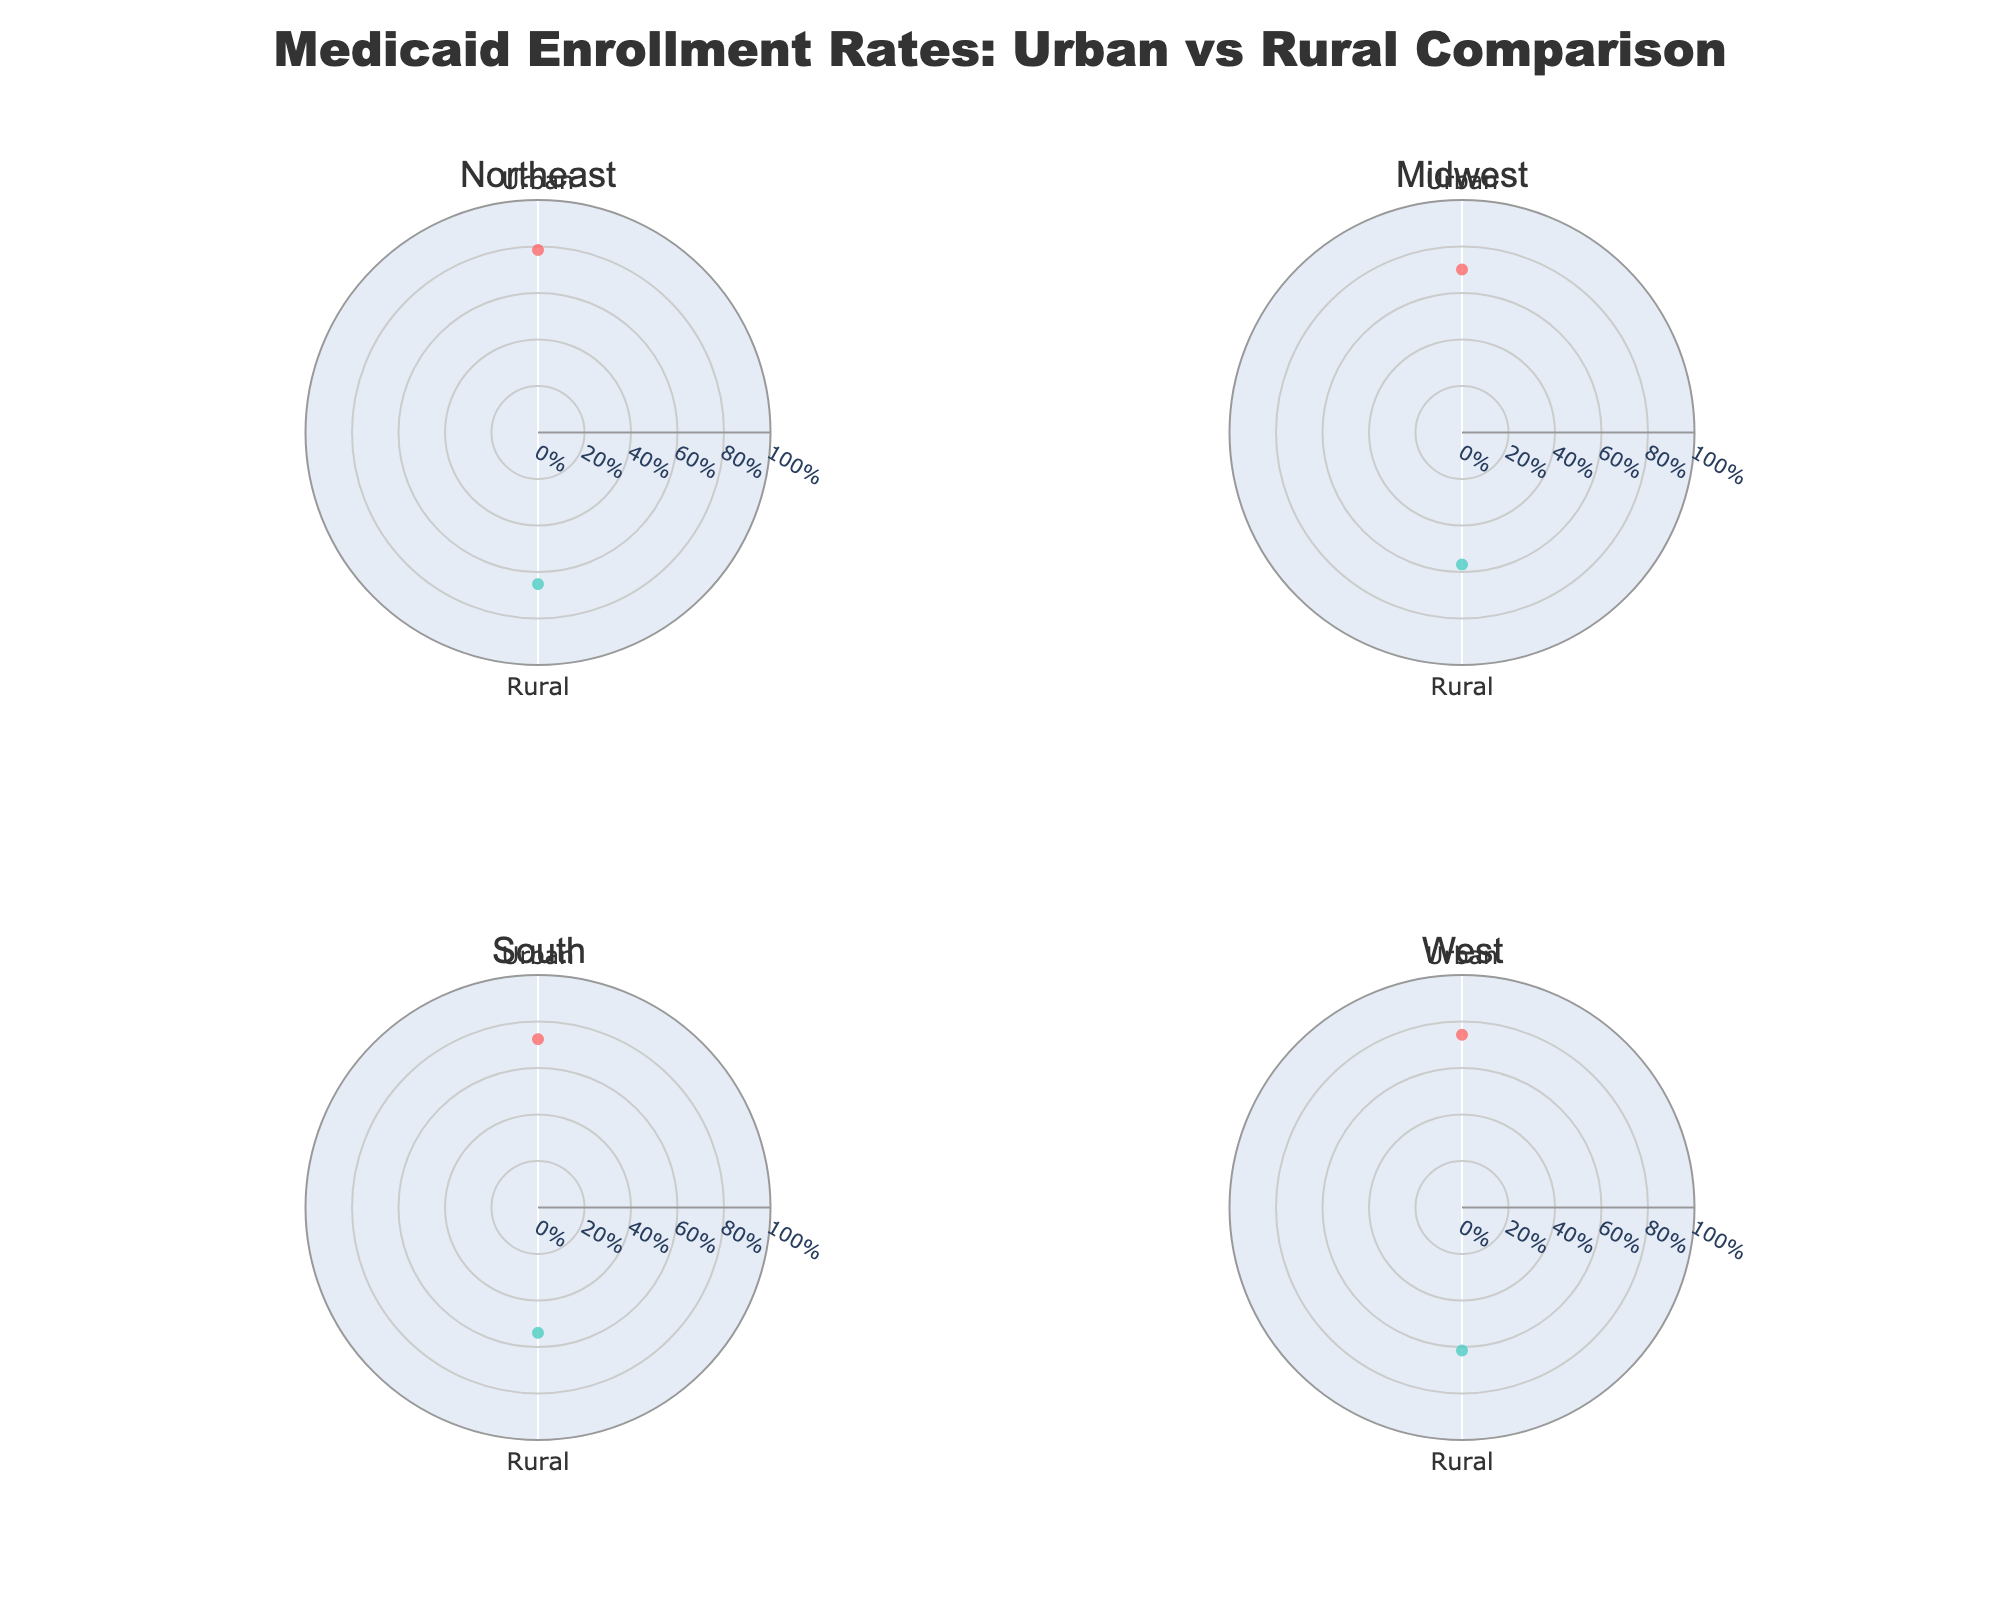Which region has the highest Medicaid enrollment rate for urban areas? The plot shows each region’s urban Medicaid enrollment rate clearly. The Northeast has the longest radial distance for the urban category.
Answer: Northeast What is the enrollment rate difference between urban and rural areas in the South? The South region's plot shows the urban enrollment rate as 72.4% and the rural enrollment rate as 53.9%. The difference is determined by subtracting the rural rate from the urban rate: 72.4% - 53.9% = 18.5%.
Answer: 18.5% Which has a higher enrollment rate in the Midwest, urban or rural areas? By comparing the radial distances for Midwest urban (70.1%) and rural (56.8%), it's evident that urban has a higher enrollment rate.
Answer: Urban Arrange the regions from highest to lowest Medicaid enrollment rate for rural areas. Looking at the radial distances for the rural category in each subplot: Northeast (65.2%), West (61.5%), Midwest (56.8%), and South (53.9%).
Answer: Northeast, West, Midwest, South What is the average enrollment rate for urban areas across all regions? To get the average: (78.5% + 70.1% + 72.4% + 74.3%) / 4 = 73.825%.
Answer: 73.825% How does the enrollment rate for rural areas in the West compare to urban areas in the Midwest? The West rural enrollment rate is 61.5% and the Midwest urban enrollment rate is 70.1%. Since 61.5% is less than 70.1%, the rural rate in the West is lower.
Answer: Lower What is the enrollment rate range for the Northeast? In the Northeast region's plot, urban is 78.5% and rural is 65.2%. The range is 78.5% - 65.2% = 13.3%.
Answer: 13.3% Which region shows the smallest difference between urban and rural Medicaid enrollment rates? By comparing differences: 
Northeast (78.5% - 65.2% = 13.3%), 
Midwest (70.1% - 56.8% = 13.3%), 
South (72.4% - 53.9% = 18.5%), 
West (74.3% - 61.5% = 12.8%). 
The West has the smallest difference of 12.8%.
Answer: West How many regions have a rural enrollment rate above 60%? By reviewing each subplot's rural category: 
Northeast (65.2%), 
West (61.5%). 
Thus, 2 regions have rural rates above 60%.
Answer: 2 